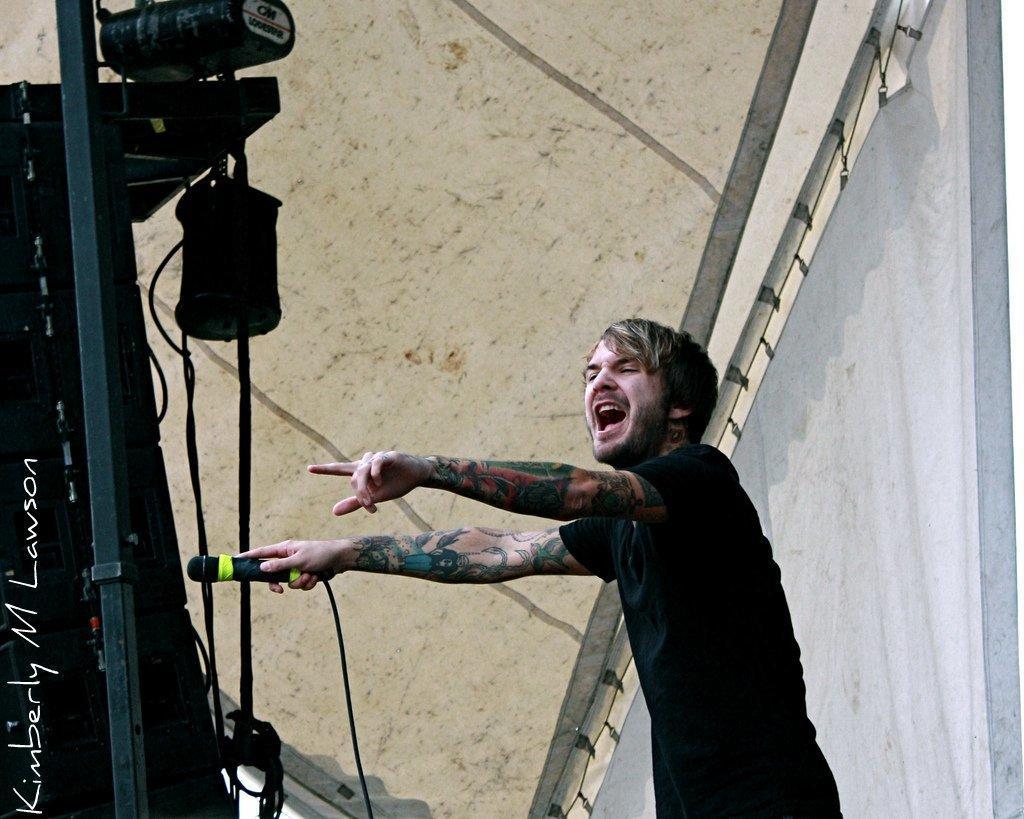Could you give a brief overview of what you see in this image? In this image in the center there is a person standing and holding a mic and having some expression on his face. On the left side there are lights and there is an object which is black in colour, there are wires, on the right side there is a curtain. 